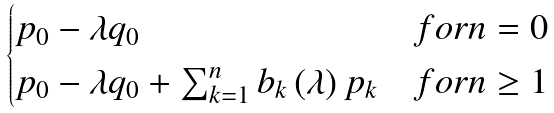<formula> <loc_0><loc_0><loc_500><loc_500>\begin{cases} p _ { 0 } - \lambda q _ { 0 } & f o r n = 0 \\ p _ { 0 } - \lambda q _ { 0 } + \sum _ { k = 1 } ^ { n } b _ { k } \left ( \lambda \right ) p _ { k } & f o r n \geq 1 \end{cases}</formula> 